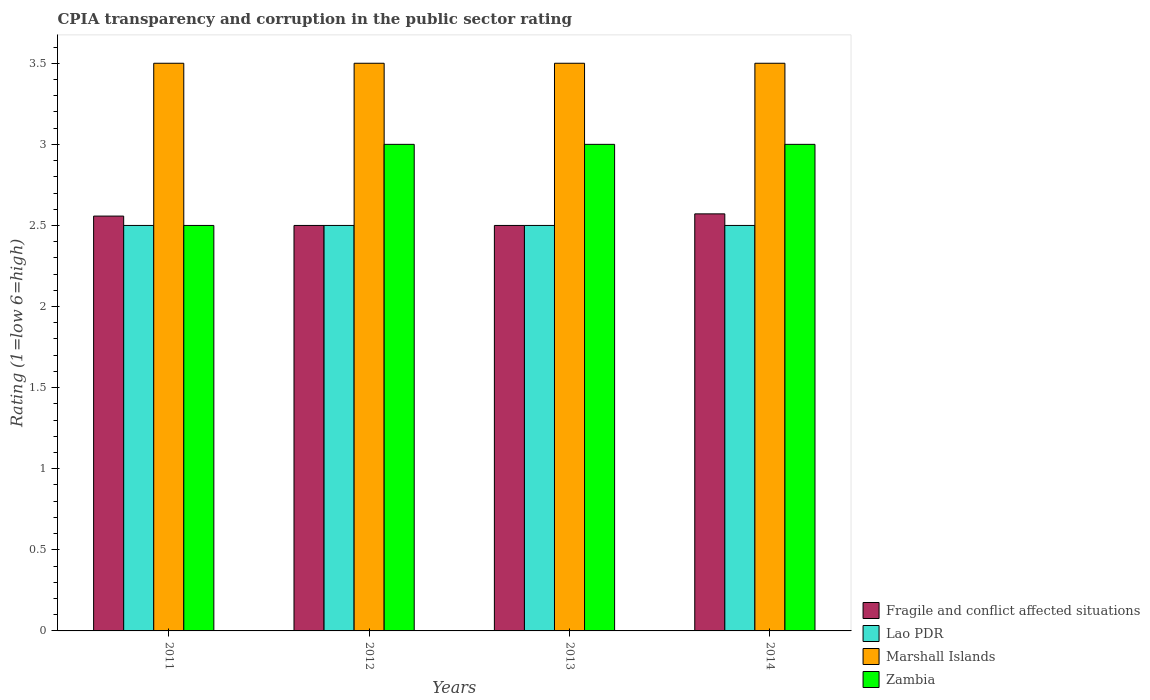How many groups of bars are there?
Your answer should be compact. 4. Are the number of bars on each tick of the X-axis equal?
Your answer should be very brief. Yes. How many bars are there on the 3rd tick from the left?
Provide a succinct answer. 4. Across all years, what is the minimum CPIA rating in Marshall Islands?
Provide a short and direct response. 3.5. What is the total CPIA rating in Fragile and conflict affected situations in the graph?
Provide a short and direct response. 10.13. What is the difference between the CPIA rating in Marshall Islands in 2011 and that in 2014?
Keep it short and to the point. 0. In the year 2011, what is the difference between the CPIA rating in Fragile and conflict affected situations and CPIA rating in Lao PDR?
Make the answer very short. 0.06. What is the ratio of the CPIA rating in Marshall Islands in 2011 to that in 2012?
Offer a terse response. 1. Is the difference between the CPIA rating in Fragile and conflict affected situations in 2011 and 2013 greater than the difference between the CPIA rating in Lao PDR in 2011 and 2013?
Your answer should be compact. Yes. In how many years, is the CPIA rating in Fragile and conflict affected situations greater than the average CPIA rating in Fragile and conflict affected situations taken over all years?
Your answer should be compact. 2. What does the 2nd bar from the left in 2014 represents?
Provide a short and direct response. Lao PDR. What does the 2nd bar from the right in 2013 represents?
Offer a terse response. Marshall Islands. Is it the case that in every year, the sum of the CPIA rating in Marshall Islands and CPIA rating in Fragile and conflict affected situations is greater than the CPIA rating in Lao PDR?
Your answer should be very brief. Yes. How many bars are there?
Provide a short and direct response. 16. Are all the bars in the graph horizontal?
Your response must be concise. No. Does the graph contain any zero values?
Offer a terse response. No. Where does the legend appear in the graph?
Your response must be concise. Bottom right. What is the title of the graph?
Offer a terse response. CPIA transparency and corruption in the public sector rating. Does "Curacao" appear as one of the legend labels in the graph?
Provide a short and direct response. No. What is the label or title of the Y-axis?
Make the answer very short. Rating (1=low 6=high). What is the Rating (1=low 6=high) in Fragile and conflict affected situations in 2011?
Give a very brief answer. 2.56. What is the Rating (1=low 6=high) of Lao PDR in 2011?
Provide a succinct answer. 2.5. What is the Rating (1=low 6=high) in Zambia in 2011?
Your response must be concise. 2.5. What is the Rating (1=low 6=high) in Marshall Islands in 2012?
Offer a terse response. 3.5. What is the Rating (1=low 6=high) of Zambia in 2012?
Provide a succinct answer. 3. What is the Rating (1=low 6=high) of Fragile and conflict affected situations in 2013?
Offer a terse response. 2.5. What is the Rating (1=low 6=high) in Lao PDR in 2013?
Your answer should be very brief. 2.5. What is the Rating (1=low 6=high) of Marshall Islands in 2013?
Your answer should be compact. 3.5. What is the Rating (1=low 6=high) of Fragile and conflict affected situations in 2014?
Your answer should be very brief. 2.57. Across all years, what is the maximum Rating (1=low 6=high) of Fragile and conflict affected situations?
Keep it short and to the point. 2.57. Across all years, what is the maximum Rating (1=low 6=high) in Lao PDR?
Your response must be concise. 2.5. Across all years, what is the minimum Rating (1=low 6=high) of Fragile and conflict affected situations?
Your answer should be compact. 2.5. What is the total Rating (1=low 6=high) in Fragile and conflict affected situations in the graph?
Your response must be concise. 10.13. What is the total Rating (1=low 6=high) of Lao PDR in the graph?
Offer a terse response. 10. What is the total Rating (1=low 6=high) in Marshall Islands in the graph?
Offer a terse response. 14. What is the total Rating (1=low 6=high) of Zambia in the graph?
Ensure brevity in your answer.  11.5. What is the difference between the Rating (1=low 6=high) of Fragile and conflict affected situations in 2011 and that in 2012?
Offer a terse response. 0.06. What is the difference between the Rating (1=low 6=high) of Lao PDR in 2011 and that in 2012?
Give a very brief answer. 0. What is the difference between the Rating (1=low 6=high) in Marshall Islands in 2011 and that in 2012?
Offer a terse response. 0. What is the difference between the Rating (1=low 6=high) of Fragile and conflict affected situations in 2011 and that in 2013?
Ensure brevity in your answer.  0.06. What is the difference between the Rating (1=low 6=high) of Lao PDR in 2011 and that in 2013?
Your answer should be very brief. 0. What is the difference between the Rating (1=low 6=high) of Marshall Islands in 2011 and that in 2013?
Offer a terse response. 0. What is the difference between the Rating (1=low 6=high) of Fragile and conflict affected situations in 2011 and that in 2014?
Ensure brevity in your answer.  -0.01. What is the difference between the Rating (1=low 6=high) of Lao PDR in 2011 and that in 2014?
Offer a terse response. 0. What is the difference between the Rating (1=low 6=high) of Fragile and conflict affected situations in 2012 and that in 2013?
Offer a terse response. 0. What is the difference between the Rating (1=low 6=high) of Marshall Islands in 2012 and that in 2013?
Ensure brevity in your answer.  0. What is the difference between the Rating (1=low 6=high) of Fragile and conflict affected situations in 2012 and that in 2014?
Your answer should be very brief. -0.07. What is the difference between the Rating (1=low 6=high) in Lao PDR in 2012 and that in 2014?
Your response must be concise. 0. What is the difference between the Rating (1=low 6=high) in Marshall Islands in 2012 and that in 2014?
Make the answer very short. 0. What is the difference between the Rating (1=low 6=high) in Fragile and conflict affected situations in 2013 and that in 2014?
Provide a succinct answer. -0.07. What is the difference between the Rating (1=low 6=high) in Zambia in 2013 and that in 2014?
Your response must be concise. 0. What is the difference between the Rating (1=low 6=high) in Fragile and conflict affected situations in 2011 and the Rating (1=low 6=high) in Lao PDR in 2012?
Your answer should be compact. 0.06. What is the difference between the Rating (1=low 6=high) in Fragile and conflict affected situations in 2011 and the Rating (1=low 6=high) in Marshall Islands in 2012?
Your answer should be compact. -0.94. What is the difference between the Rating (1=low 6=high) of Fragile and conflict affected situations in 2011 and the Rating (1=low 6=high) of Zambia in 2012?
Provide a short and direct response. -0.44. What is the difference between the Rating (1=low 6=high) in Marshall Islands in 2011 and the Rating (1=low 6=high) in Zambia in 2012?
Offer a very short reply. 0.5. What is the difference between the Rating (1=low 6=high) in Fragile and conflict affected situations in 2011 and the Rating (1=low 6=high) in Lao PDR in 2013?
Ensure brevity in your answer.  0.06. What is the difference between the Rating (1=low 6=high) of Fragile and conflict affected situations in 2011 and the Rating (1=low 6=high) of Marshall Islands in 2013?
Provide a short and direct response. -0.94. What is the difference between the Rating (1=low 6=high) of Fragile and conflict affected situations in 2011 and the Rating (1=low 6=high) of Zambia in 2013?
Ensure brevity in your answer.  -0.44. What is the difference between the Rating (1=low 6=high) in Lao PDR in 2011 and the Rating (1=low 6=high) in Zambia in 2013?
Offer a terse response. -0.5. What is the difference between the Rating (1=low 6=high) of Fragile and conflict affected situations in 2011 and the Rating (1=low 6=high) of Lao PDR in 2014?
Make the answer very short. 0.06. What is the difference between the Rating (1=low 6=high) in Fragile and conflict affected situations in 2011 and the Rating (1=low 6=high) in Marshall Islands in 2014?
Keep it short and to the point. -0.94. What is the difference between the Rating (1=low 6=high) of Fragile and conflict affected situations in 2011 and the Rating (1=low 6=high) of Zambia in 2014?
Your answer should be compact. -0.44. What is the difference between the Rating (1=low 6=high) in Lao PDR in 2011 and the Rating (1=low 6=high) in Marshall Islands in 2014?
Your response must be concise. -1. What is the difference between the Rating (1=low 6=high) of Lao PDR in 2011 and the Rating (1=low 6=high) of Zambia in 2014?
Give a very brief answer. -0.5. What is the difference between the Rating (1=low 6=high) in Fragile and conflict affected situations in 2012 and the Rating (1=low 6=high) in Zambia in 2013?
Make the answer very short. -0.5. What is the difference between the Rating (1=low 6=high) in Lao PDR in 2012 and the Rating (1=low 6=high) in Marshall Islands in 2013?
Your answer should be very brief. -1. What is the difference between the Rating (1=low 6=high) of Marshall Islands in 2012 and the Rating (1=low 6=high) of Zambia in 2013?
Offer a very short reply. 0.5. What is the difference between the Rating (1=low 6=high) of Fragile and conflict affected situations in 2012 and the Rating (1=low 6=high) of Lao PDR in 2014?
Provide a succinct answer. 0. What is the difference between the Rating (1=low 6=high) in Fragile and conflict affected situations in 2012 and the Rating (1=low 6=high) in Marshall Islands in 2014?
Keep it short and to the point. -1. What is the difference between the Rating (1=low 6=high) of Fragile and conflict affected situations in 2012 and the Rating (1=low 6=high) of Zambia in 2014?
Ensure brevity in your answer.  -0.5. What is the difference between the Rating (1=low 6=high) in Lao PDR in 2012 and the Rating (1=low 6=high) in Marshall Islands in 2014?
Provide a succinct answer. -1. What is the difference between the Rating (1=low 6=high) in Lao PDR in 2012 and the Rating (1=low 6=high) in Zambia in 2014?
Your answer should be very brief. -0.5. What is the difference between the Rating (1=low 6=high) of Marshall Islands in 2012 and the Rating (1=low 6=high) of Zambia in 2014?
Your response must be concise. 0.5. What is the difference between the Rating (1=low 6=high) of Fragile and conflict affected situations in 2013 and the Rating (1=low 6=high) of Zambia in 2014?
Keep it short and to the point. -0.5. What is the difference between the Rating (1=low 6=high) of Lao PDR in 2013 and the Rating (1=low 6=high) of Zambia in 2014?
Your response must be concise. -0.5. What is the average Rating (1=low 6=high) of Fragile and conflict affected situations per year?
Provide a short and direct response. 2.53. What is the average Rating (1=low 6=high) of Lao PDR per year?
Keep it short and to the point. 2.5. What is the average Rating (1=low 6=high) of Zambia per year?
Your answer should be very brief. 2.88. In the year 2011, what is the difference between the Rating (1=low 6=high) in Fragile and conflict affected situations and Rating (1=low 6=high) in Lao PDR?
Give a very brief answer. 0.06. In the year 2011, what is the difference between the Rating (1=low 6=high) of Fragile and conflict affected situations and Rating (1=low 6=high) of Marshall Islands?
Keep it short and to the point. -0.94. In the year 2011, what is the difference between the Rating (1=low 6=high) in Fragile and conflict affected situations and Rating (1=low 6=high) in Zambia?
Give a very brief answer. 0.06. In the year 2011, what is the difference between the Rating (1=low 6=high) in Marshall Islands and Rating (1=low 6=high) in Zambia?
Your response must be concise. 1. In the year 2012, what is the difference between the Rating (1=low 6=high) in Fragile and conflict affected situations and Rating (1=low 6=high) in Lao PDR?
Give a very brief answer. 0. In the year 2012, what is the difference between the Rating (1=low 6=high) of Fragile and conflict affected situations and Rating (1=low 6=high) of Zambia?
Offer a terse response. -0.5. In the year 2012, what is the difference between the Rating (1=low 6=high) of Lao PDR and Rating (1=low 6=high) of Zambia?
Offer a terse response. -0.5. In the year 2013, what is the difference between the Rating (1=low 6=high) in Fragile and conflict affected situations and Rating (1=low 6=high) in Marshall Islands?
Your answer should be compact. -1. In the year 2013, what is the difference between the Rating (1=low 6=high) in Lao PDR and Rating (1=low 6=high) in Marshall Islands?
Your answer should be compact. -1. In the year 2014, what is the difference between the Rating (1=low 6=high) of Fragile and conflict affected situations and Rating (1=low 6=high) of Lao PDR?
Keep it short and to the point. 0.07. In the year 2014, what is the difference between the Rating (1=low 6=high) of Fragile and conflict affected situations and Rating (1=low 6=high) of Marshall Islands?
Ensure brevity in your answer.  -0.93. In the year 2014, what is the difference between the Rating (1=low 6=high) of Fragile and conflict affected situations and Rating (1=low 6=high) of Zambia?
Your response must be concise. -0.43. In the year 2014, what is the difference between the Rating (1=low 6=high) of Lao PDR and Rating (1=low 6=high) of Marshall Islands?
Give a very brief answer. -1. In the year 2014, what is the difference between the Rating (1=low 6=high) in Lao PDR and Rating (1=low 6=high) in Zambia?
Provide a short and direct response. -0.5. What is the ratio of the Rating (1=low 6=high) of Fragile and conflict affected situations in 2011 to that in 2012?
Provide a short and direct response. 1.02. What is the ratio of the Rating (1=low 6=high) in Zambia in 2011 to that in 2012?
Your answer should be compact. 0.83. What is the ratio of the Rating (1=low 6=high) in Fragile and conflict affected situations in 2011 to that in 2013?
Provide a short and direct response. 1.02. What is the ratio of the Rating (1=low 6=high) in Lao PDR in 2011 to that in 2013?
Offer a terse response. 1. What is the ratio of the Rating (1=low 6=high) of Marshall Islands in 2011 to that in 2013?
Provide a short and direct response. 1. What is the ratio of the Rating (1=low 6=high) of Lao PDR in 2011 to that in 2014?
Ensure brevity in your answer.  1. What is the ratio of the Rating (1=low 6=high) in Zambia in 2011 to that in 2014?
Your answer should be compact. 0.83. What is the ratio of the Rating (1=low 6=high) in Fragile and conflict affected situations in 2012 to that in 2013?
Provide a short and direct response. 1. What is the ratio of the Rating (1=low 6=high) in Zambia in 2012 to that in 2013?
Your answer should be very brief. 1. What is the ratio of the Rating (1=low 6=high) in Fragile and conflict affected situations in 2012 to that in 2014?
Provide a short and direct response. 0.97. What is the ratio of the Rating (1=low 6=high) of Lao PDR in 2012 to that in 2014?
Your response must be concise. 1. What is the ratio of the Rating (1=low 6=high) in Zambia in 2012 to that in 2014?
Provide a succinct answer. 1. What is the ratio of the Rating (1=low 6=high) of Fragile and conflict affected situations in 2013 to that in 2014?
Ensure brevity in your answer.  0.97. What is the ratio of the Rating (1=low 6=high) in Lao PDR in 2013 to that in 2014?
Give a very brief answer. 1. What is the ratio of the Rating (1=low 6=high) of Marshall Islands in 2013 to that in 2014?
Offer a very short reply. 1. What is the difference between the highest and the second highest Rating (1=low 6=high) of Fragile and conflict affected situations?
Your answer should be compact. 0.01. What is the difference between the highest and the second highest Rating (1=low 6=high) of Lao PDR?
Offer a terse response. 0. What is the difference between the highest and the second highest Rating (1=low 6=high) of Zambia?
Your answer should be very brief. 0. What is the difference between the highest and the lowest Rating (1=low 6=high) of Fragile and conflict affected situations?
Keep it short and to the point. 0.07. What is the difference between the highest and the lowest Rating (1=low 6=high) in Zambia?
Provide a short and direct response. 0.5. 